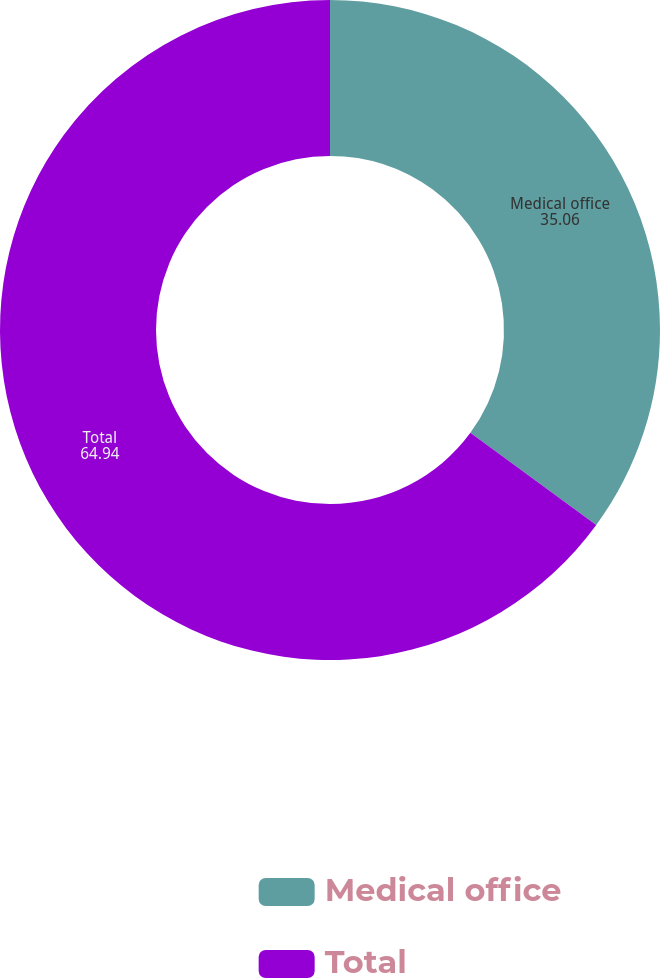Convert chart. <chart><loc_0><loc_0><loc_500><loc_500><pie_chart><fcel>Medical office<fcel>Total<nl><fcel>35.06%<fcel>64.94%<nl></chart> 